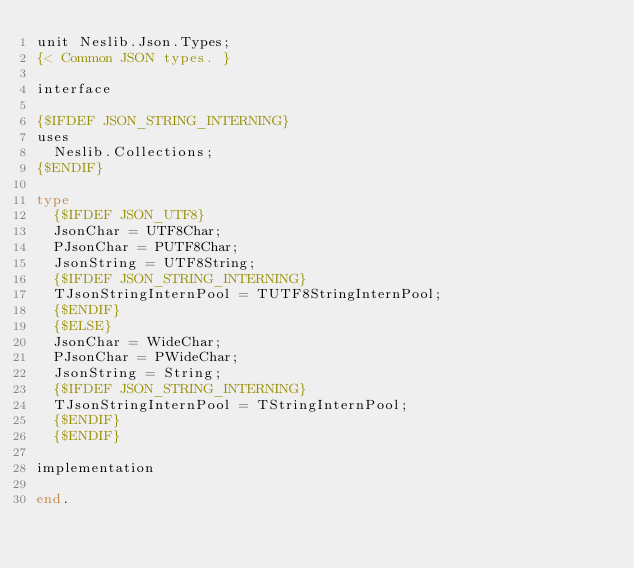Convert code to text. <code><loc_0><loc_0><loc_500><loc_500><_Pascal_>unit Neslib.Json.Types;
{< Common JSON types. }

interface

{$IFDEF JSON_STRING_INTERNING}
uses
  Neslib.Collections;
{$ENDIF}

type
  {$IFDEF JSON_UTF8}
  JsonChar = UTF8Char;
  PJsonChar = PUTF8Char;
  JsonString = UTF8String;
  {$IFDEF JSON_STRING_INTERNING}
  TJsonStringInternPool = TUTF8StringInternPool;
  {$ENDIF}
  {$ELSE}
  JsonChar = WideChar;
  PJsonChar = PWideChar;
  JsonString = String;
  {$IFDEF JSON_STRING_INTERNING}
  TJsonStringInternPool = TStringInternPool;
  {$ENDIF}
  {$ENDIF}

implementation

end.
</code> 